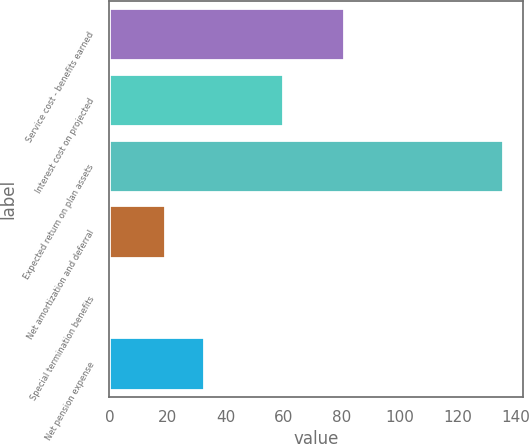<chart> <loc_0><loc_0><loc_500><loc_500><bar_chart><fcel>Service cost - benefits earned<fcel>Interest cost on projected<fcel>Expected return on plan assets<fcel>Net amortization and deferral<fcel>Special termination benefits<fcel>Net pension expense<nl><fcel>80.8<fcel>60<fcel>135.8<fcel>19.1<fcel>0.1<fcel>32.67<nl></chart> 